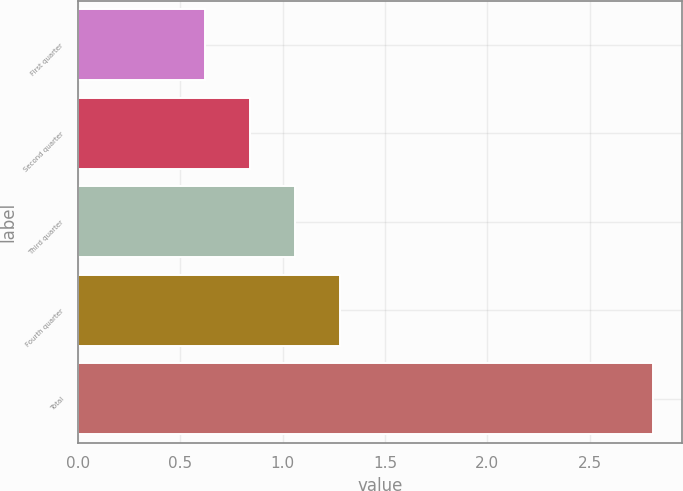Convert chart. <chart><loc_0><loc_0><loc_500><loc_500><bar_chart><fcel>First quarter<fcel>Second quarter<fcel>Third quarter<fcel>Fourth quarter<fcel>Total<nl><fcel>0.62<fcel>0.84<fcel>1.06<fcel>1.28<fcel>2.81<nl></chart> 